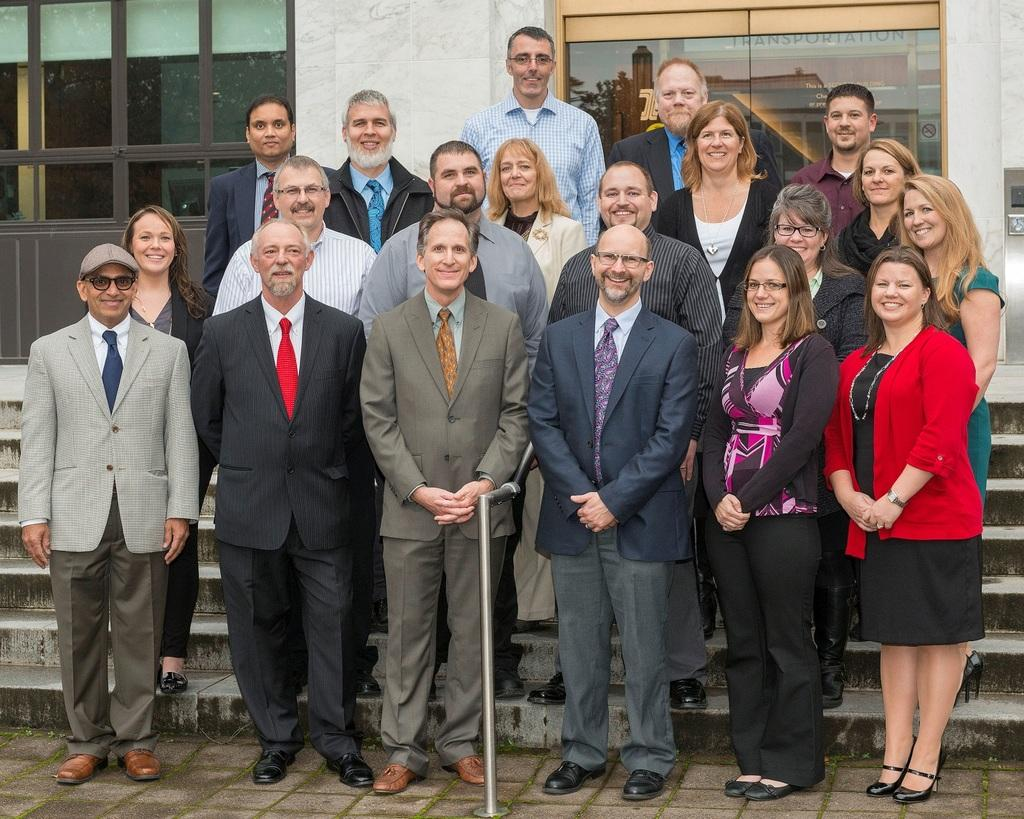How many people are in the image? There is a group of people in the image. What is the facial expression of the people in the image? The people are smiling. What can be seen in the background of the image? There is a wall and glasses in the background of the image. What is reflected on the glasses? The reflection of a building is visible on the glasses. Are there any signs of disgust on the faces of the people in the image? No, the people in the image are smiling, which suggests a positive or happy emotion rather than disgust. 